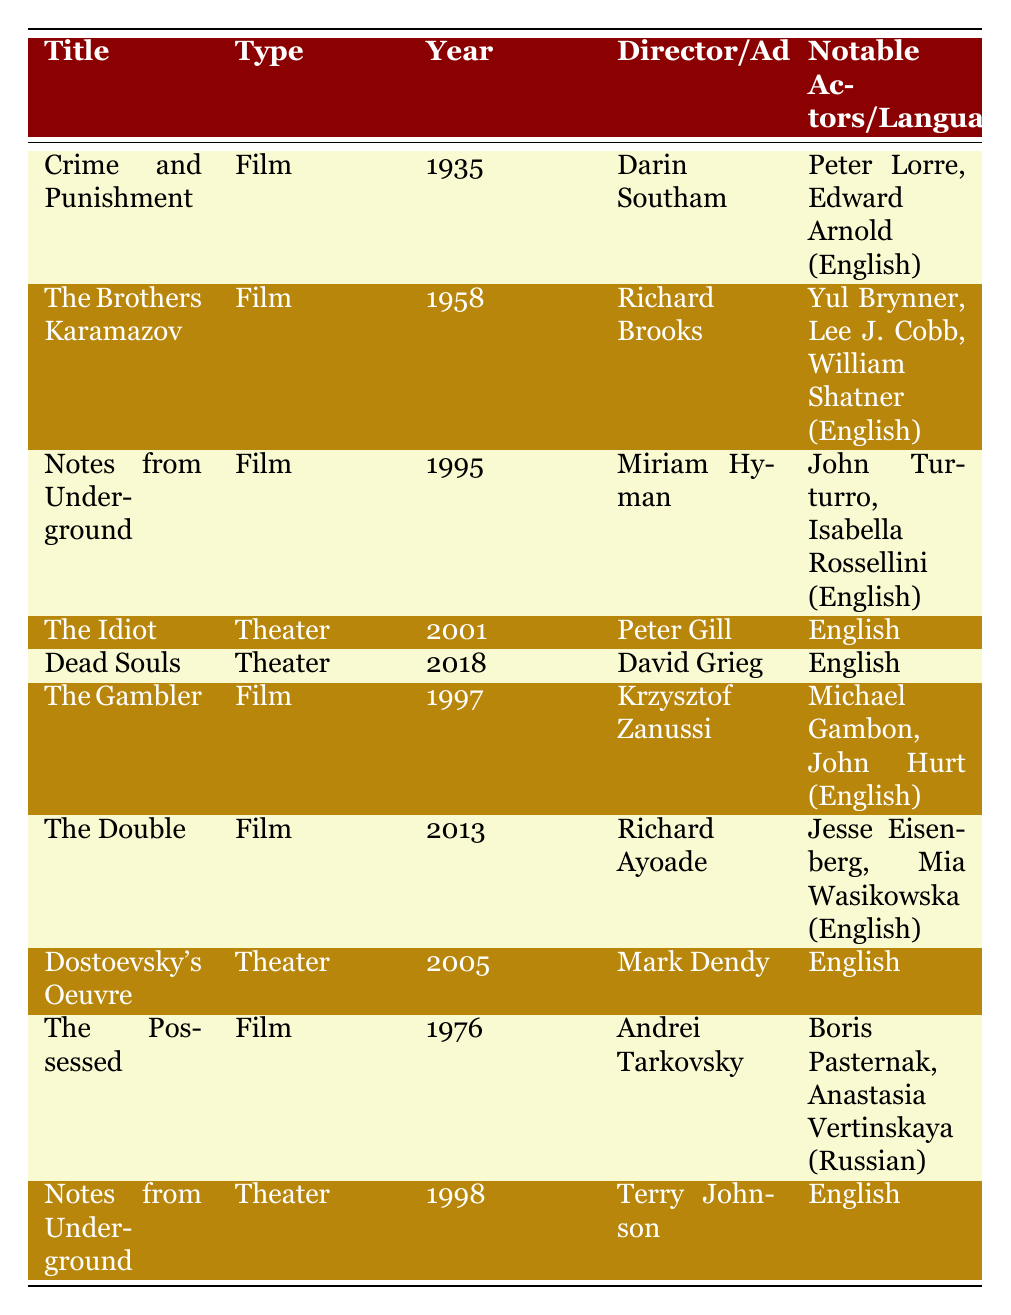What is the title of the film directed by Darin Southam? The table lists "Crime and Punishment" with Darin Southam as the director under the Film type.
Answer: Crime and Punishment How many adaptations of Dostoevsky's works are listed as films? The table shows 6 entries under the Film type: "Crime and Punishment", "The Brothers Karamazov", "Notes from Underground", "The Gambler", "The Double", and "The Possessed".
Answer: 6 Which film adaptation features notable actors Peter Lorre and Edward Arnold? From the table, "Crime and Punishment" is associated with Peter Lorre and Edward Arnold under notable actors.
Answer: Crime and Punishment Is "The Possessed" the only film directed by Andrei Tarkovsky in the table? The table indicates that "The Possessed" is indeed the only film listed that is directed by Andrei Tarkovsky.
Answer: Yes What is the earliest year of adaptation for Dostoevsky's works as listed in the table? The table shows that the earliest year of adaptation is 1935, corresponding to "Crime and Punishment".
Answer: 1935 How many theater adaptations are there that were made in the 2000s? There are two theater adaptations in the 2000s: "The Idiot" (2001) and "Dostoevsky's Oeuvre" (2005), as seen in the table.
Answer: 2 What is the language of the adaptation of "Dead Souls"? The table specifies that "Dead Souls," which is a theater adaptation, is in English.
Answer: English Which adaptation has the most recent release year? According to the table, the most recent release year is 2018 for the theater adaptation "Dead Souls".
Answer: 2018 Which adaptation was performed in Russian? The only adaptation in Russian listed in the table is "The Possessed".
Answer: The Possessed 